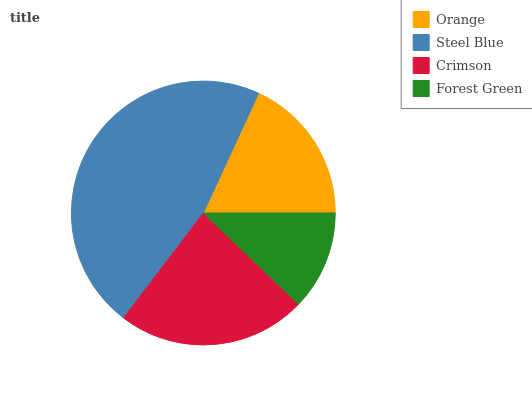Is Forest Green the minimum?
Answer yes or no. Yes. Is Steel Blue the maximum?
Answer yes or no. Yes. Is Crimson the minimum?
Answer yes or no. No. Is Crimson the maximum?
Answer yes or no. No. Is Steel Blue greater than Crimson?
Answer yes or no. Yes. Is Crimson less than Steel Blue?
Answer yes or no. Yes. Is Crimson greater than Steel Blue?
Answer yes or no. No. Is Steel Blue less than Crimson?
Answer yes or no. No. Is Crimson the high median?
Answer yes or no. Yes. Is Orange the low median?
Answer yes or no. Yes. Is Steel Blue the high median?
Answer yes or no. No. Is Crimson the low median?
Answer yes or no. No. 